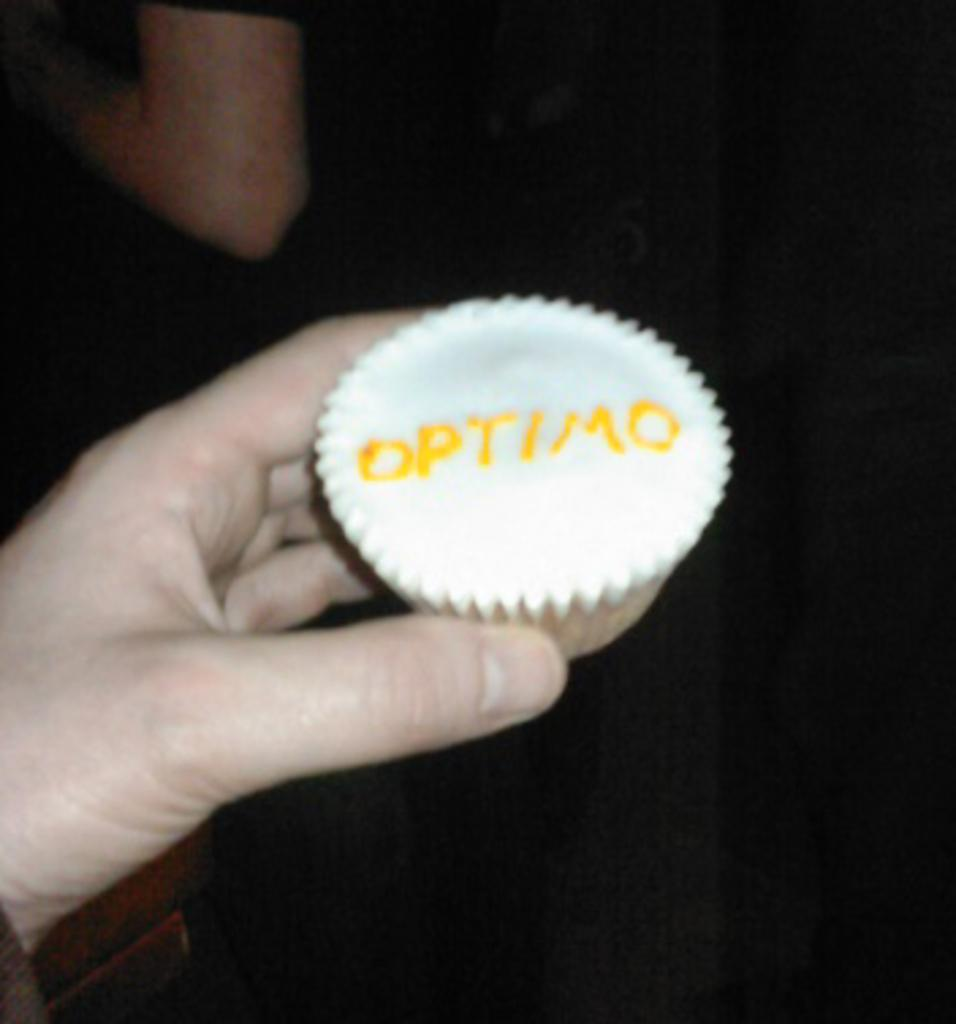What can be seen in the person's hand in the image? The hand is holding a cupcake. What is written on the cupcake? There is writing on the cupcake. How would you describe the overall lighting in the image? The background of the image is dark. What type of machine is being used to crack the code on the cupcake? There is no machine or code present in the image; it simply shows a person's hand holding a cupcake with writing on it. 